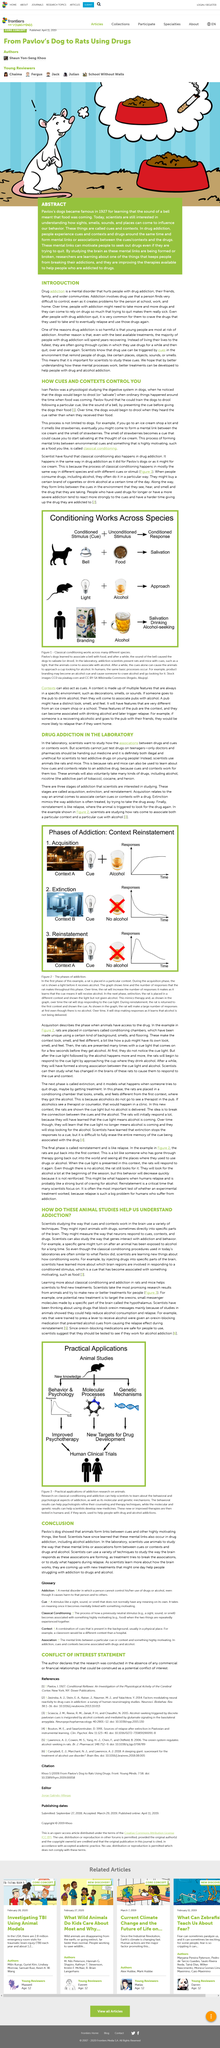List a handful of essential elements in this visual. Addiction, characterized by drug use that is difficult to control despite causing problems in various aspects of a person's life, such as school, work, and home, is a prevalent phenomenon. The dogs drooled in response to the cue, rather than when they received the food, demonstrating that the cues and contexts controlled their behavior. It is unethical and illegal for scientists to test addictive drugs on young people, and it is only doctors and pharmacists who should be handing out medicine. Therefore, it is imperative to prevent scientists from conducting such tests on teenagers. Yes, it is very common for people with drug addiction to crave the drugs even after they quit, according to the introduction. Yes, mental links also occur in drug addiction. 